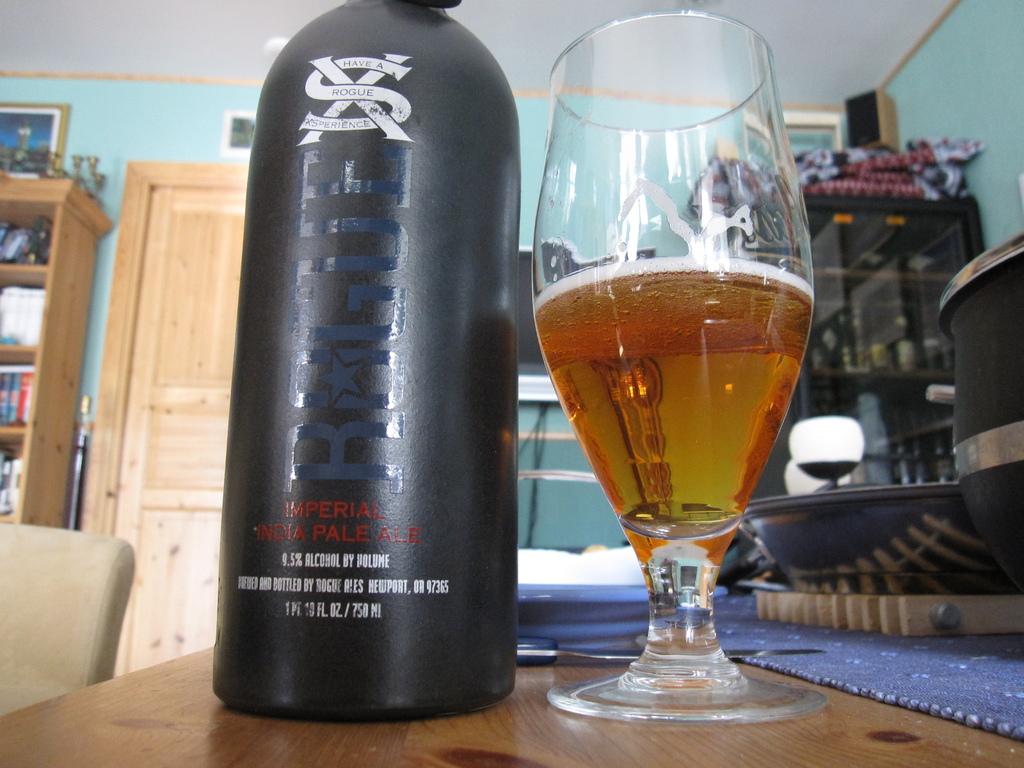What drink is that bottle?
Keep it short and to the point. Ale. Whta´s the brand of this drink?
Provide a succinct answer. Rogue. 